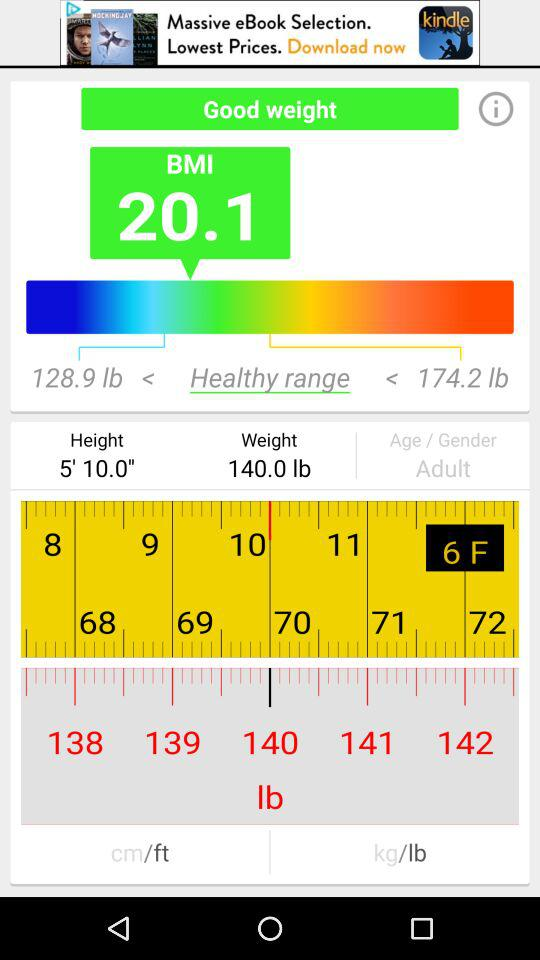What is the maximum height range?
When the provided information is insufficient, respond with <no answer>. <no answer> 